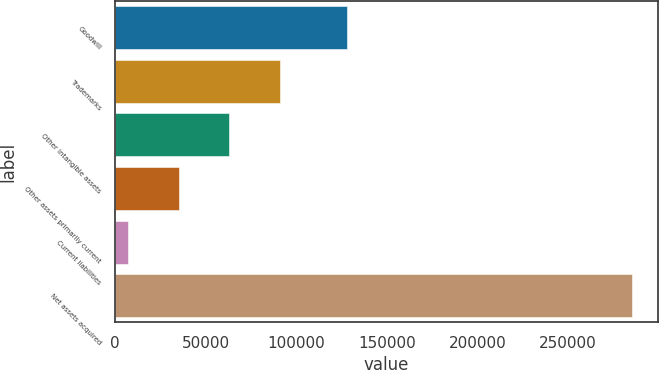Convert chart. <chart><loc_0><loc_0><loc_500><loc_500><bar_chart><fcel>Goodwill<fcel>Trademarks<fcel>Other intangible assets<fcel>Other assets primarily current<fcel>Current liabilities<fcel>Net assets acquired<nl><fcel>128110<fcel>91200<fcel>62843.6<fcel>35027.3<fcel>7211<fcel>285374<nl></chart> 